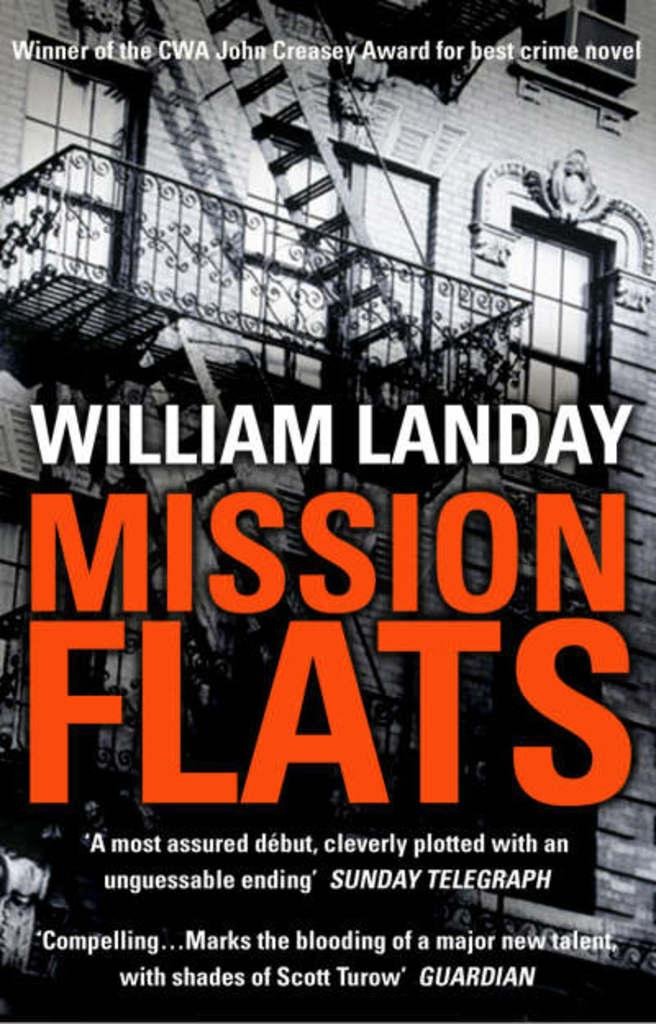<image>
Summarize the visual content of the image. Mission Flats is the winner of the CWA John Creasey Award for best crime novel. 